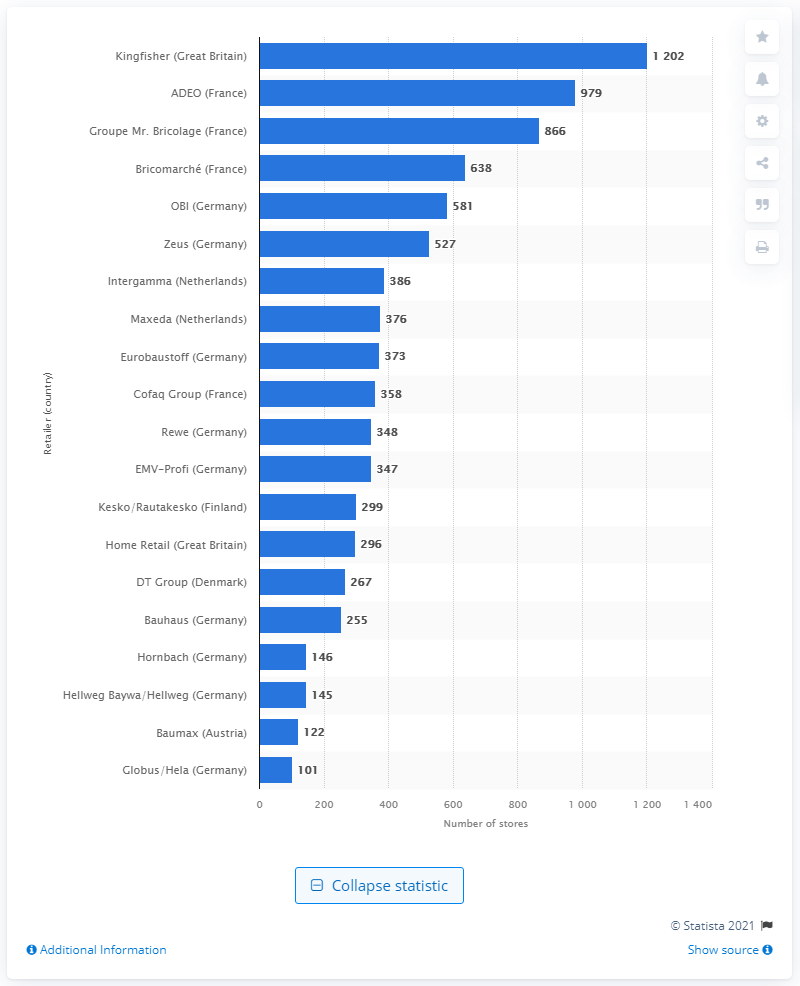How many stores did Kingfisher operate in 2014? In the year 2014, Kingfisher PLC, which is a leading home improvement retailer based in the United Kingdom, showcased a strong retail network by operating an impressive 1,202 stores across various regions. The organization's expansive presence is indicative of its significant role in the home improvement sector at that time. 